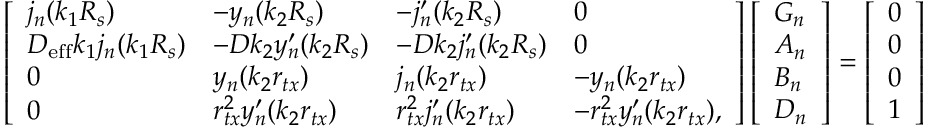Convert formula to latex. <formula><loc_0><loc_0><loc_500><loc_500>\left [ \begin{array} { l l l l } { j _ { n } ( k _ { 1 } R _ { s } ) } & { - y _ { n } ( k _ { 2 } R _ { s } ) } & { - j _ { n } ^ { \prime } ( k _ { 2 } R _ { s } ) } & { 0 } \\ { D _ { e f f } k _ { 1 } j _ { n } ( k _ { 1 } R _ { s } ) } & { - D k _ { 2 } y _ { n } ^ { \prime } ( k _ { 2 } R _ { s } ) } & { - D k _ { 2 } j _ { n } ^ { \prime } ( k _ { 2 } R _ { s } ) } & { 0 } \\ { 0 } & { y _ { n } ( k _ { 2 } r _ { t x } ) } & { j _ { n } ( k _ { 2 } r _ { t x } ) } & { - y _ { n } ( k _ { 2 } r _ { t x } ) } \\ { 0 } & { r _ { t x } ^ { 2 } y _ { n } ^ { \prime } ( k _ { 2 } r _ { t x } ) } & { r _ { t x } ^ { 2 } j _ { n } ^ { \prime } ( k _ { 2 } r _ { t x } ) } & { - r _ { t x } ^ { 2 } y _ { n } ^ { \prime } ( k _ { 2 } r _ { t x } ) , } \end{array} \right ] \left [ \begin{array} { l } { G _ { n } } \\ { A _ { n } } \\ { B _ { n } } \\ { D _ { n } } \end{array} \right ] = \left [ \begin{array} { l } { 0 } \\ { 0 } \\ { 0 } \\ { 1 } \end{array} \right ]</formula> 